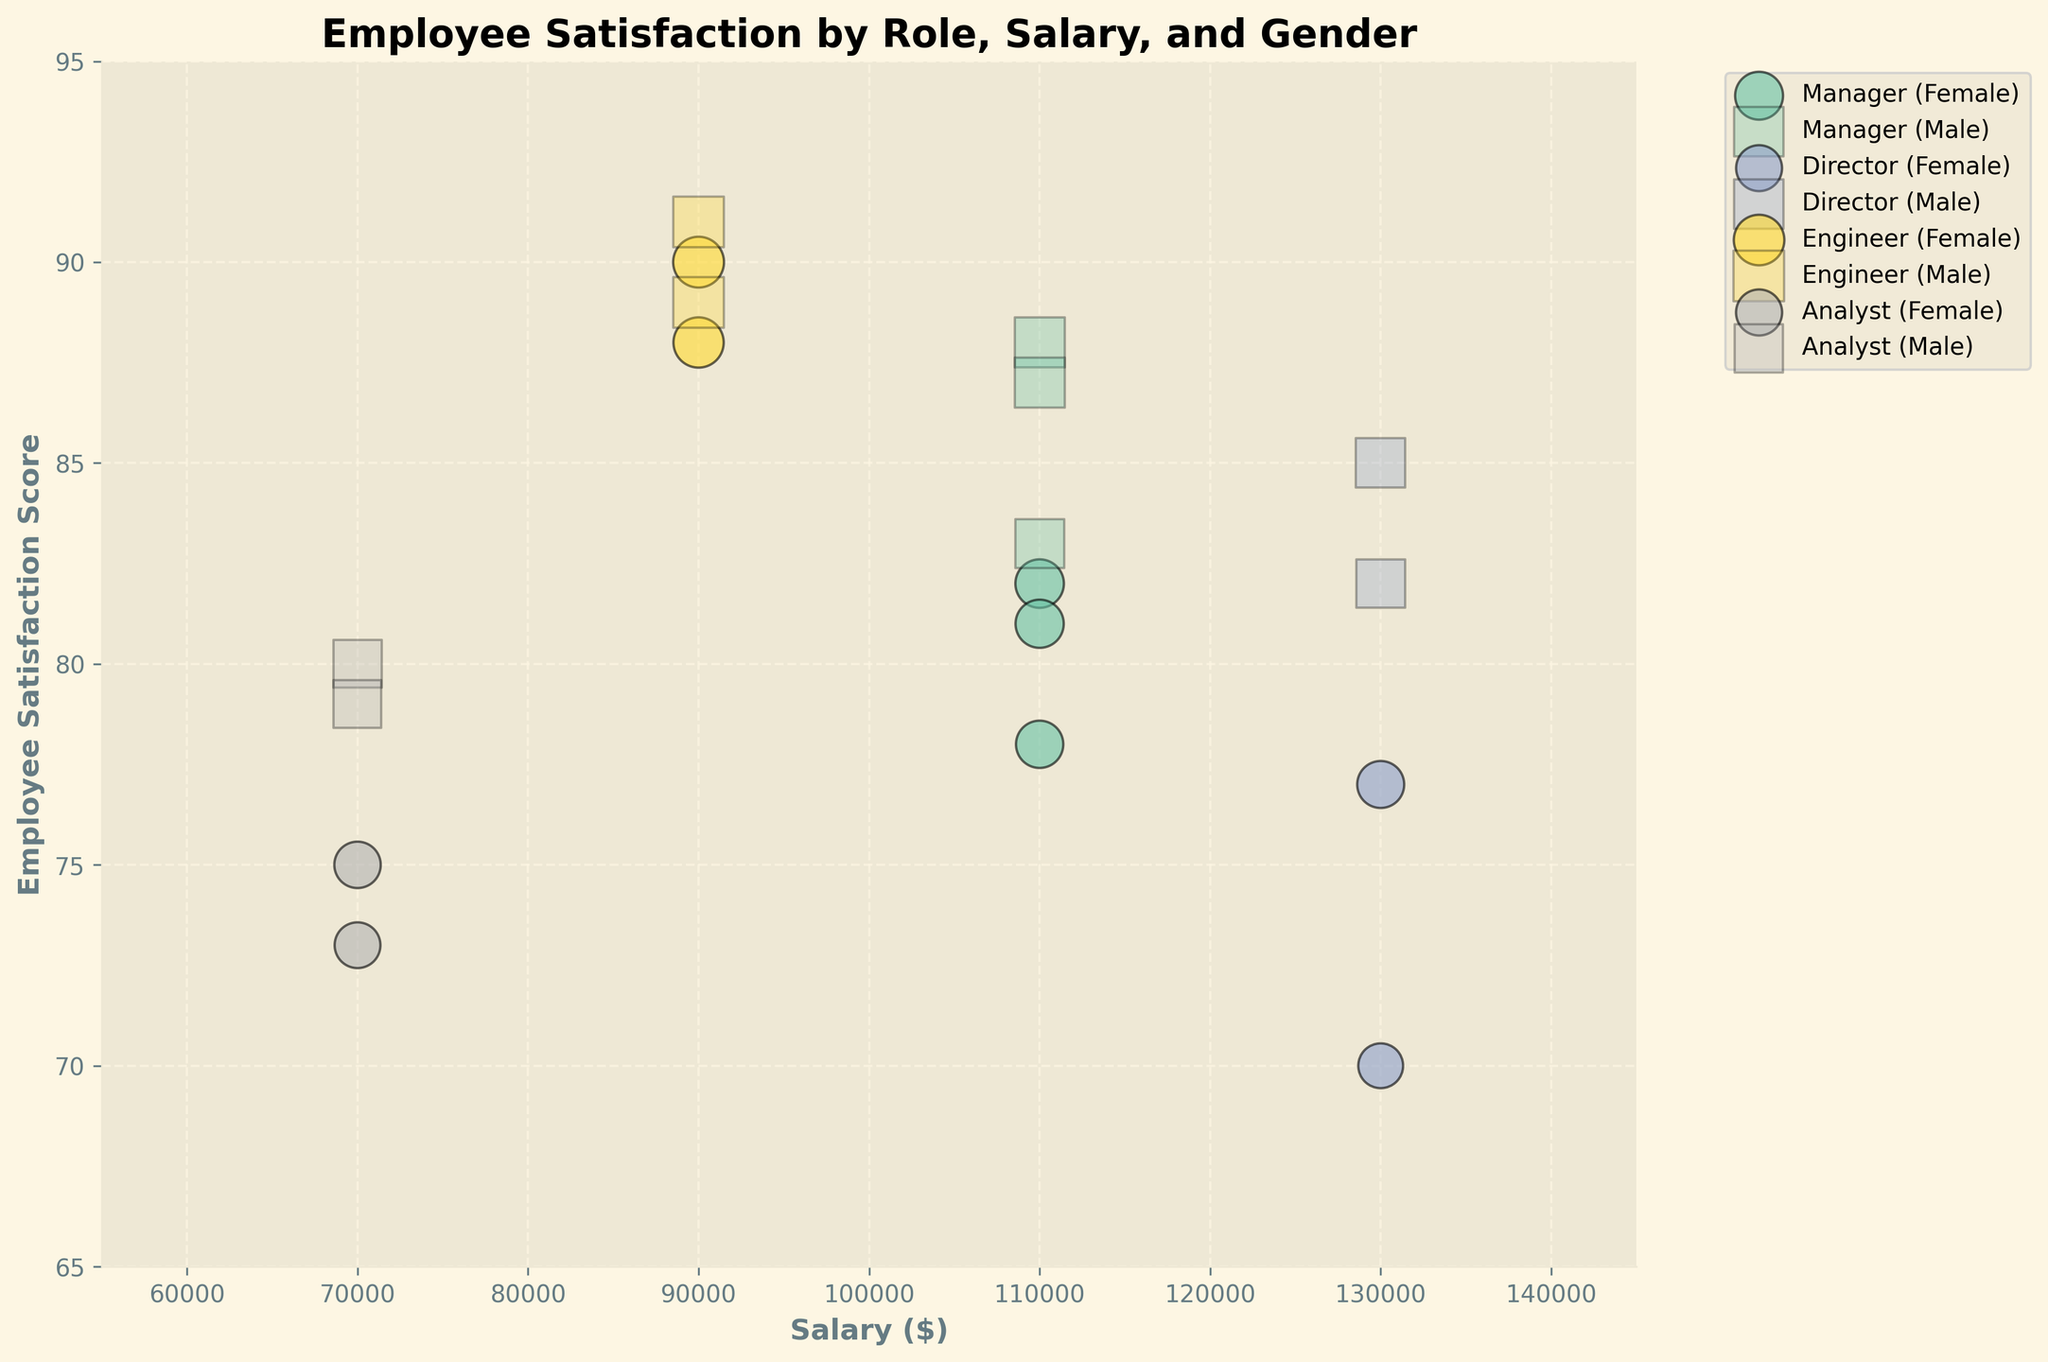what is the title of the figure? The title is displayed at the top center of the figure. It summarizes the overall theme of the chart.
Answer: Employee Satisfaction by Role, Salary, and Gender which gender has higher satisfaction scores in the Director role? To determine this, compare the satisfaction scores for both genders within the Director role.
Answer: Male between the female engineers and male engineers, who has a higher average satisfaction score? Calculate the average satisfaction for female engineers (90 and 88) and male engineers (89 and 91).
Answer: Male engineers how many roles are represented in the figure? Count the unique roles displayed in the legend of the figure.
Answer: 4 what's the salary range displayed on the x-axis? The x-axis represents the salary range, and it's labeled with specific values at the ends.
Answer: $55,000 to $145,000 how do the satisfaction scores of female analysts compare to male analysts? Compare the satisfaction scores of female analysts (75, 73) with those of male analysts (80, 79).
Answer: Male analysts have higher scores is there a higher satisfaction score for female or male managers? Compare the satisfaction scores of female and male managers.
Answer: Male managers what's the range of satisfaction scores visible on the y-axis? The y-axis represents the satisfaction scores, and it is labeled with specific values at the top and bottom.
Answer: 65 to 95 how does the satisfaction score of male engineers in the $80,000-$100,000 salary bracket compare to that of female engineers in the same bracket? Check the data points for both male and female engineers within the $80,000-$100,000 salary bracket and compare their satisfaction scores (Male: 91, 89 and Female: 90, 88).
Answer: Male engineers have slightly higher satisfaction scores are there any roles where the average satisfaction scores of males and females are equal? Calculate the average satisfaction scores for each gender within each role and compare them. None of the roles show equal average scores for both genders.
Answer: No 